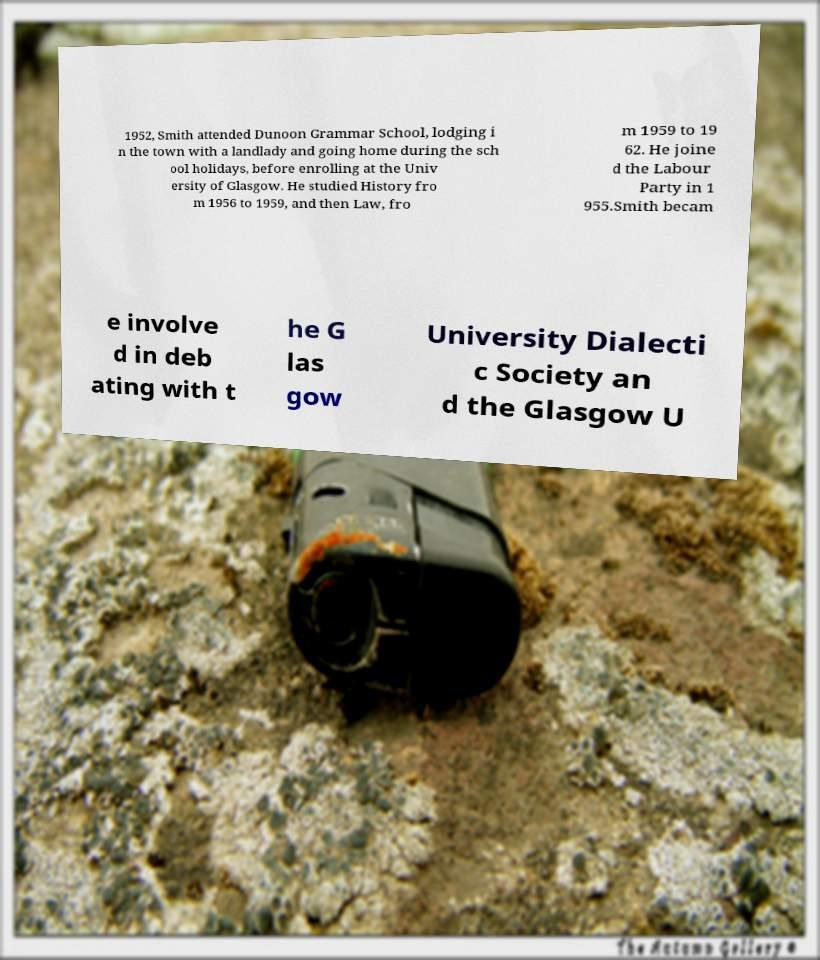Please identify and transcribe the text found in this image. 1952, Smith attended Dunoon Grammar School, lodging i n the town with a landlady and going home during the sch ool holidays, before enrolling at the Univ ersity of Glasgow. He studied History fro m 1956 to 1959, and then Law, fro m 1959 to 19 62. He joine d the Labour Party in 1 955.Smith becam e involve d in deb ating with t he G las gow University Dialecti c Society an d the Glasgow U 